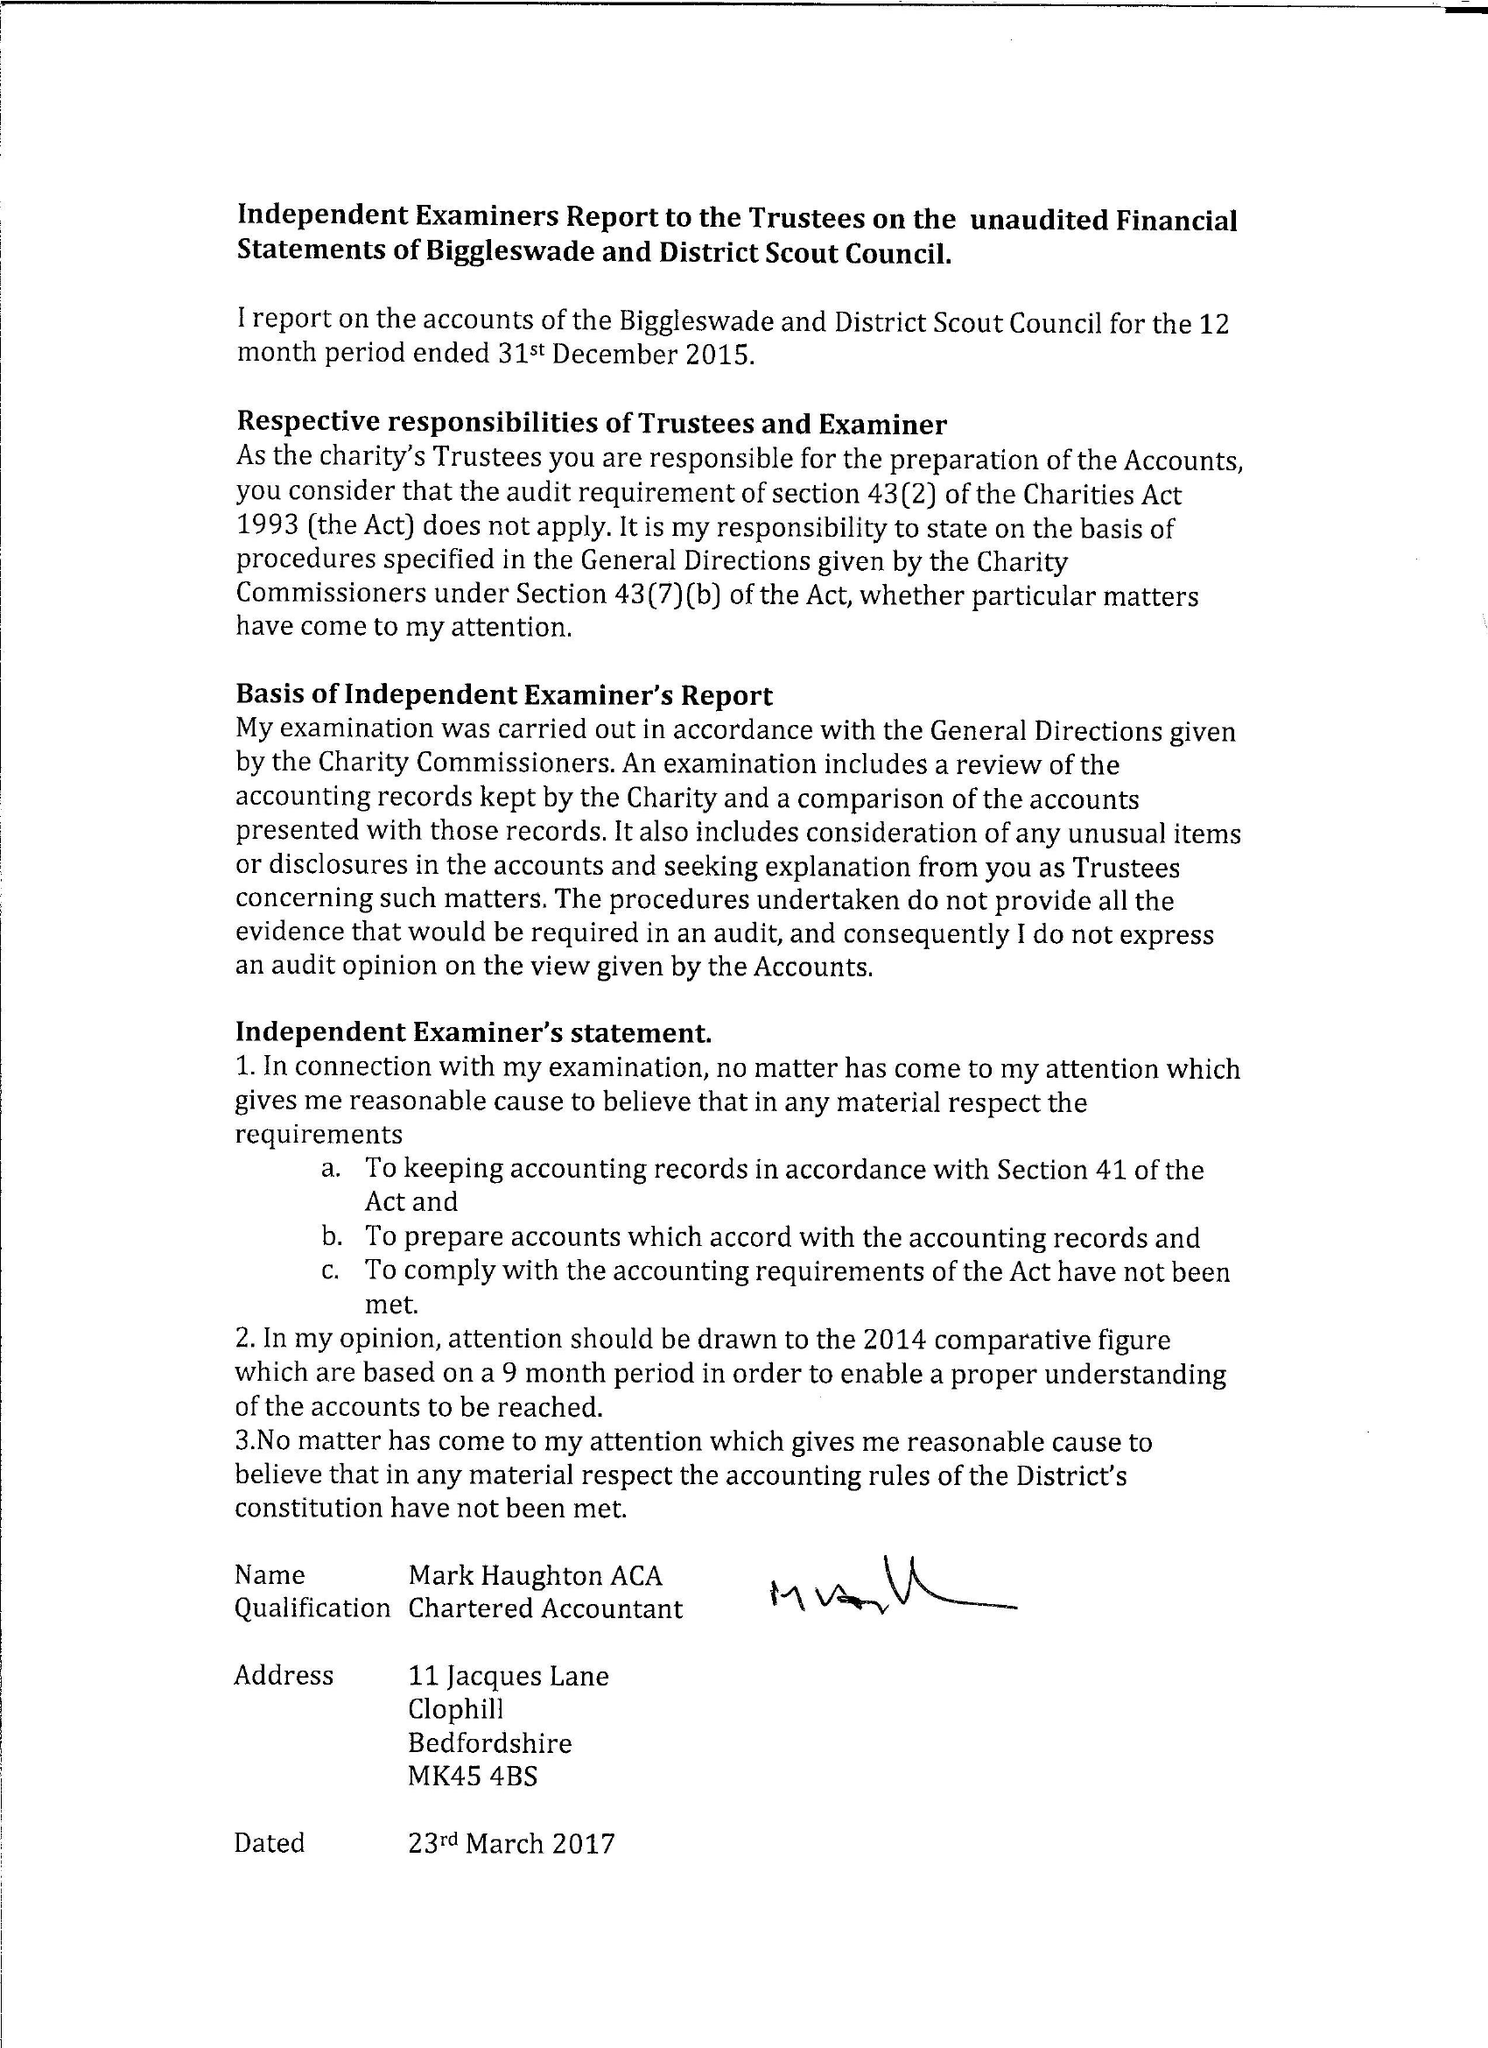What is the value for the address__postcode?
Answer the question using a single word or phrase. SG18 0RQ 